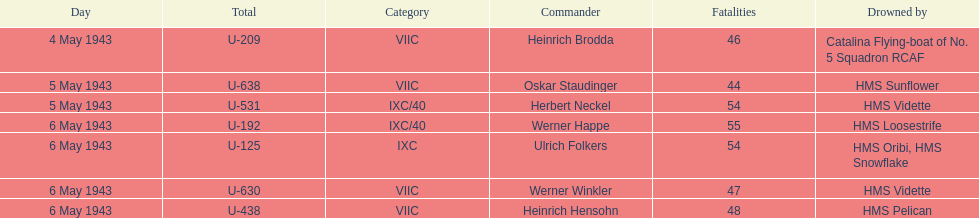What is the difference in the number of casualties on may 6 compared to may 4? 158. 